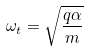Convert formula to latex. <formula><loc_0><loc_0><loc_500><loc_500>\omega _ { t } = \sqrt { \frac { q \alpha } { m } }</formula> 